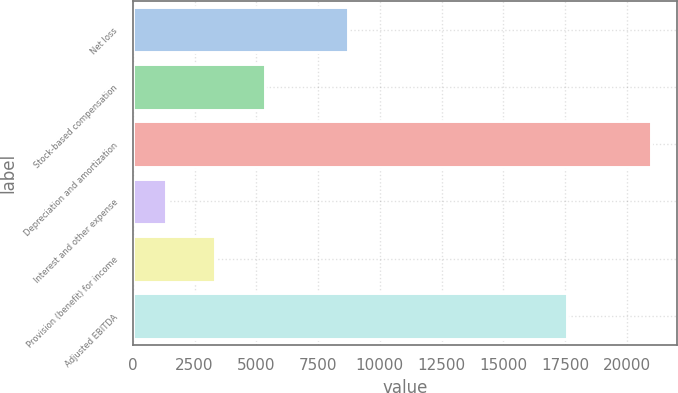Convert chart to OTSL. <chart><loc_0><loc_0><loc_500><loc_500><bar_chart><fcel>Net loss<fcel>Stock-based compensation<fcel>Depreciation and amortization<fcel>Interest and other expense<fcel>Provision (benefit) for income<fcel>Adjusted EBITDA<nl><fcel>8705<fcel>5346<fcel>21001<fcel>1357<fcel>3321.4<fcel>17571<nl></chart> 